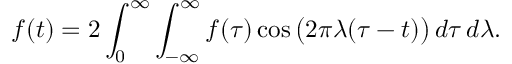<formula> <loc_0><loc_0><loc_500><loc_500>f ( t ) = 2 \int _ { 0 } ^ { \infty } \int _ { - \infty } ^ { \infty } f ( \tau ) \cos { \left ( } 2 \pi \lambda ( \tau - t ) { \right ) } \, d \tau \, d \lambda .</formula> 